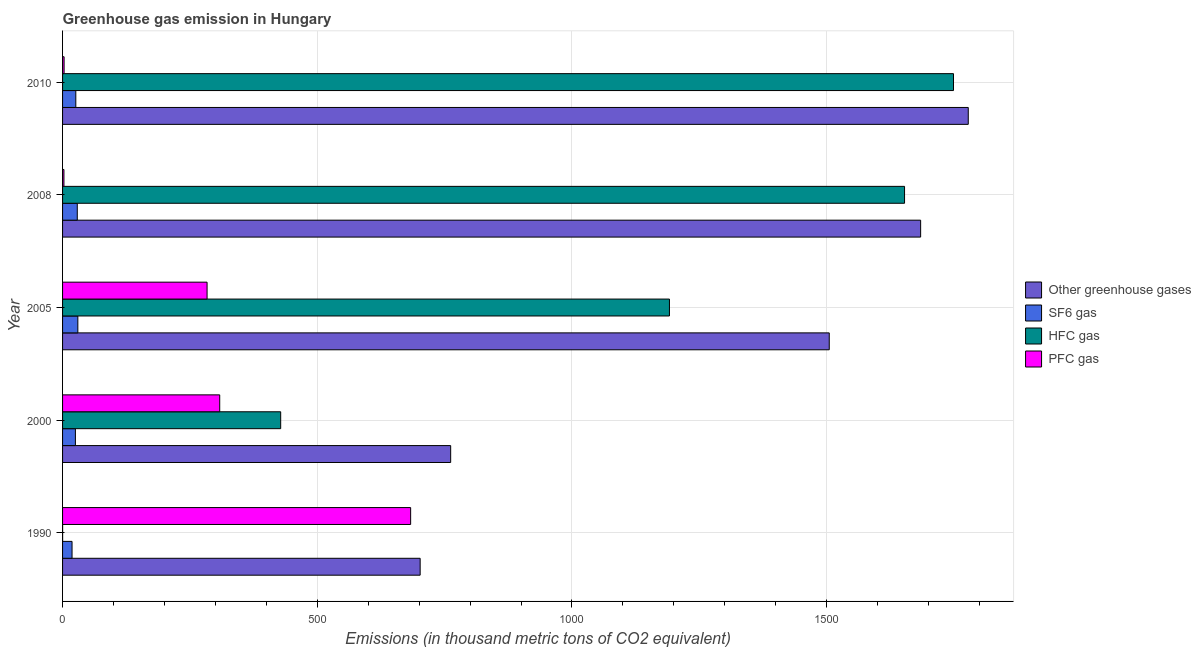How many bars are there on the 1st tick from the bottom?
Keep it short and to the point. 4. Across all years, what is the maximum emission of sf6 gas?
Ensure brevity in your answer.  30. What is the total emission of sf6 gas in the graph?
Make the answer very short. 128.7. What is the difference between the emission of pfc gas in 2005 and that in 2008?
Your answer should be compact. 281. What is the difference between the emission of greenhouse gases in 2000 and the emission of hfc gas in 2008?
Your answer should be compact. -891. What is the average emission of greenhouse gases per year?
Ensure brevity in your answer.  1286.3. In the year 2010, what is the difference between the emission of sf6 gas and emission of hfc gas?
Make the answer very short. -1723. What is the ratio of the emission of hfc gas in 2000 to that in 2008?
Offer a terse response. 0.26. Is the emission of pfc gas in 2000 less than that in 2005?
Offer a very short reply. No. Is the difference between the emission of hfc gas in 2000 and 2008 greater than the difference between the emission of pfc gas in 2000 and 2008?
Your answer should be compact. No. What is the difference between the highest and the second highest emission of sf6 gas?
Your response must be concise. 1.1. What is the difference between the highest and the lowest emission of hfc gas?
Give a very brief answer. 1748.9. In how many years, is the emission of hfc gas greater than the average emission of hfc gas taken over all years?
Your response must be concise. 3. Is the sum of the emission of hfc gas in 2005 and 2008 greater than the maximum emission of sf6 gas across all years?
Provide a short and direct response. Yes. What does the 2nd bar from the top in 2005 represents?
Ensure brevity in your answer.  HFC gas. What does the 3rd bar from the bottom in 2008 represents?
Provide a short and direct response. HFC gas. Is it the case that in every year, the sum of the emission of greenhouse gases and emission of sf6 gas is greater than the emission of hfc gas?
Provide a short and direct response. Yes. Are all the bars in the graph horizontal?
Ensure brevity in your answer.  Yes. How many years are there in the graph?
Offer a terse response. 5. Are the values on the major ticks of X-axis written in scientific E-notation?
Provide a short and direct response. No. Does the graph contain any zero values?
Your response must be concise. No. Does the graph contain grids?
Your answer should be very brief. Yes. What is the title of the graph?
Keep it short and to the point. Greenhouse gas emission in Hungary. Does "Secondary vocational education" appear as one of the legend labels in the graph?
Provide a short and direct response. No. What is the label or title of the X-axis?
Your response must be concise. Emissions (in thousand metric tons of CO2 equivalent). What is the label or title of the Y-axis?
Your response must be concise. Year. What is the Emissions (in thousand metric tons of CO2 equivalent) in Other greenhouse gases in 1990?
Ensure brevity in your answer.  702. What is the Emissions (in thousand metric tons of CO2 equivalent) in SF6 gas in 1990?
Your answer should be very brief. 18.6. What is the Emissions (in thousand metric tons of CO2 equivalent) in PFC gas in 1990?
Provide a succinct answer. 683.3. What is the Emissions (in thousand metric tons of CO2 equivalent) of Other greenhouse gases in 2000?
Ensure brevity in your answer.  761.9. What is the Emissions (in thousand metric tons of CO2 equivalent) of SF6 gas in 2000?
Offer a very short reply. 25.2. What is the Emissions (in thousand metric tons of CO2 equivalent) in HFC gas in 2000?
Offer a terse response. 428.2. What is the Emissions (in thousand metric tons of CO2 equivalent) of PFC gas in 2000?
Provide a succinct answer. 308.5. What is the Emissions (in thousand metric tons of CO2 equivalent) of Other greenhouse gases in 2005?
Provide a succinct answer. 1505.1. What is the Emissions (in thousand metric tons of CO2 equivalent) in SF6 gas in 2005?
Provide a succinct answer. 30. What is the Emissions (in thousand metric tons of CO2 equivalent) of HFC gas in 2005?
Keep it short and to the point. 1191.4. What is the Emissions (in thousand metric tons of CO2 equivalent) of PFC gas in 2005?
Make the answer very short. 283.7. What is the Emissions (in thousand metric tons of CO2 equivalent) in Other greenhouse gases in 2008?
Keep it short and to the point. 1684.5. What is the Emissions (in thousand metric tons of CO2 equivalent) of SF6 gas in 2008?
Give a very brief answer. 28.9. What is the Emissions (in thousand metric tons of CO2 equivalent) in HFC gas in 2008?
Your response must be concise. 1652.9. What is the Emissions (in thousand metric tons of CO2 equivalent) in Other greenhouse gases in 2010?
Your answer should be compact. 1778. What is the Emissions (in thousand metric tons of CO2 equivalent) in SF6 gas in 2010?
Keep it short and to the point. 26. What is the Emissions (in thousand metric tons of CO2 equivalent) of HFC gas in 2010?
Your answer should be very brief. 1749. What is the Emissions (in thousand metric tons of CO2 equivalent) in PFC gas in 2010?
Your answer should be very brief. 3. Across all years, what is the maximum Emissions (in thousand metric tons of CO2 equivalent) of Other greenhouse gases?
Give a very brief answer. 1778. Across all years, what is the maximum Emissions (in thousand metric tons of CO2 equivalent) in SF6 gas?
Your answer should be very brief. 30. Across all years, what is the maximum Emissions (in thousand metric tons of CO2 equivalent) in HFC gas?
Offer a very short reply. 1749. Across all years, what is the maximum Emissions (in thousand metric tons of CO2 equivalent) of PFC gas?
Make the answer very short. 683.3. Across all years, what is the minimum Emissions (in thousand metric tons of CO2 equivalent) of Other greenhouse gases?
Offer a terse response. 702. Across all years, what is the minimum Emissions (in thousand metric tons of CO2 equivalent) of HFC gas?
Offer a terse response. 0.1. Across all years, what is the minimum Emissions (in thousand metric tons of CO2 equivalent) in PFC gas?
Offer a very short reply. 2.7. What is the total Emissions (in thousand metric tons of CO2 equivalent) of Other greenhouse gases in the graph?
Keep it short and to the point. 6431.5. What is the total Emissions (in thousand metric tons of CO2 equivalent) of SF6 gas in the graph?
Give a very brief answer. 128.7. What is the total Emissions (in thousand metric tons of CO2 equivalent) of HFC gas in the graph?
Your answer should be very brief. 5021.6. What is the total Emissions (in thousand metric tons of CO2 equivalent) in PFC gas in the graph?
Make the answer very short. 1281.2. What is the difference between the Emissions (in thousand metric tons of CO2 equivalent) in Other greenhouse gases in 1990 and that in 2000?
Ensure brevity in your answer.  -59.9. What is the difference between the Emissions (in thousand metric tons of CO2 equivalent) in SF6 gas in 1990 and that in 2000?
Offer a terse response. -6.6. What is the difference between the Emissions (in thousand metric tons of CO2 equivalent) of HFC gas in 1990 and that in 2000?
Offer a terse response. -428.1. What is the difference between the Emissions (in thousand metric tons of CO2 equivalent) in PFC gas in 1990 and that in 2000?
Make the answer very short. 374.8. What is the difference between the Emissions (in thousand metric tons of CO2 equivalent) of Other greenhouse gases in 1990 and that in 2005?
Offer a very short reply. -803.1. What is the difference between the Emissions (in thousand metric tons of CO2 equivalent) in HFC gas in 1990 and that in 2005?
Offer a very short reply. -1191.3. What is the difference between the Emissions (in thousand metric tons of CO2 equivalent) of PFC gas in 1990 and that in 2005?
Offer a terse response. 399.6. What is the difference between the Emissions (in thousand metric tons of CO2 equivalent) of Other greenhouse gases in 1990 and that in 2008?
Provide a succinct answer. -982.5. What is the difference between the Emissions (in thousand metric tons of CO2 equivalent) of SF6 gas in 1990 and that in 2008?
Provide a short and direct response. -10.3. What is the difference between the Emissions (in thousand metric tons of CO2 equivalent) in HFC gas in 1990 and that in 2008?
Keep it short and to the point. -1652.8. What is the difference between the Emissions (in thousand metric tons of CO2 equivalent) in PFC gas in 1990 and that in 2008?
Offer a terse response. 680.6. What is the difference between the Emissions (in thousand metric tons of CO2 equivalent) of Other greenhouse gases in 1990 and that in 2010?
Keep it short and to the point. -1076. What is the difference between the Emissions (in thousand metric tons of CO2 equivalent) in HFC gas in 1990 and that in 2010?
Your answer should be very brief. -1748.9. What is the difference between the Emissions (in thousand metric tons of CO2 equivalent) of PFC gas in 1990 and that in 2010?
Offer a terse response. 680.3. What is the difference between the Emissions (in thousand metric tons of CO2 equivalent) in Other greenhouse gases in 2000 and that in 2005?
Make the answer very short. -743.2. What is the difference between the Emissions (in thousand metric tons of CO2 equivalent) of HFC gas in 2000 and that in 2005?
Provide a short and direct response. -763.2. What is the difference between the Emissions (in thousand metric tons of CO2 equivalent) in PFC gas in 2000 and that in 2005?
Offer a very short reply. 24.8. What is the difference between the Emissions (in thousand metric tons of CO2 equivalent) in Other greenhouse gases in 2000 and that in 2008?
Offer a terse response. -922.6. What is the difference between the Emissions (in thousand metric tons of CO2 equivalent) of HFC gas in 2000 and that in 2008?
Offer a very short reply. -1224.7. What is the difference between the Emissions (in thousand metric tons of CO2 equivalent) in PFC gas in 2000 and that in 2008?
Your answer should be very brief. 305.8. What is the difference between the Emissions (in thousand metric tons of CO2 equivalent) in Other greenhouse gases in 2000 and that in 2010?
Offer a very short reply. -1016.1. What is the difference between the Emissions (in thousand metric tons of CO2 equivalent) in SF6 gas in 2000 and that in 2010?
Offer a terse response. -0.8. What is the difference between the Emissions (in thousand metric tons of CO2 equivalent) in HFC gas in 2000 and that in 2010?
Your answer should be very brief. -1320.8. What is the difference between the Emissions (in thousand metric tons of CO2 equivalent) in PFC gas in 2000 and that in 2010?
Keep it short and to the point. 305.5. What is the difference between the Emissions (in thousand metric tons of CO2 equivalent) of Other greenhouse gases in 2005 and that in 2008?
Provide a short and direct response. -179.4. What is the difference between the Emissions (in thousand metric tons of CO2 equivalent) in HFC gas in 2005 and that in 2008?
Your response must be concise. -461.5. What is the difference between the Emissions (in thousand metric tons of CO2 equivalent) of PFC gas in 2005 and that in 2008?
Ensure brevity in your answer.  281. What is the difference between the Emissions (in thousand metric tons of CO2 equivalent) in Other greenhouse gases in 2005 and that in 2010?
Make the answer very short. -272.9. What is the difference between the Emissions (in thousand metric tons of CO2 equivalent) of SF6 gas in 2005 and that in 2010?
Your response must be concise. 4. What is the difference between the Emissions (in thousand metric tons of CO2 equivalent) in HFC gas in 2005 and that in 2010?
Provide a short and direct response. -557.6. What is the difference between the Emissions (in thousand metric tons of CO2 equivalent) of PFC gas in 2005 and that in 2010?
Your response must be concise. 280.7. What is the difference between the Emissions (in thousand metric tons of CO2 equivalent) in Other greenhouse gases in 2008 and that in 2010?
Your answer should be compact. -93.5. What is the difference between the Emissions (in thousand metric tons of CO2 equivalent) in SF6 gas in 2008 and that in 2010?
Give a very brief answer. 2.9. What is the difference between the Emissions (in thousand metric tons of CO2 equivalent) in HFC gas in 2008 and that in 2010?
Provide a short and direct response. -96.1. What is the difference between the Emissions (in thousand metric tons of CO2 equivalent) in Other greenhouse gases in 1990 and the Emissions (in thousand metric tons of CO2 equivalent) in SF6 gas in 2000?
Make the answer very short. 676.8. What is the difference between the Emissions (in thousand metric tons of CO2 equivalent) of Other greenhouse gases in 1990 and the Emissions (in thousand metric tons of CO2 equivalent) of HFC gas in 2000?
Your response must be concise. 273.8. What is the difference between the Emissions (in thousand metric tons of CO2 equivalent) of Other greenhouse gases in 1990 and the Emissions (in thousand metric tons of CO2 equivalent) of PFC gas in 2000?
Offer a very short reply. 393.5. What is the difference between the Emissions (in thousand metric tons of CO2 equivalent) of SF6 gas in 1990 and the Emissions (in thousand metric tons of CO2 equivalent) of HFC gas in 2000?
Your answer should be very brief. -409.6. What is the difference between the Emissions (in thousand metric tons of CO2 equivalent) of SF6 gas in 1990 and the Emissions (in thousand metric tons of CO2 equivalent) of PFC gas in 2000?
Offer a very short reply. -289.9. What is the difference between the Emissions (in thousand metric tons of CO2 equivalent) of HFC gas in 1990 and the Emissions (in thousand metric tons of CO2 equivalent) of PFC gas in 2000?
Your response must be concise. -308.4. What is the difference between the Emissions (in thousand metric tons of CO2 equivalent) of Other greenhouse gases in 1990 and the Emissions (in thousand metric tons of CO2 equivalent) of SF6 gas in 2005?
Give a very brief answer. 672. What is the difference between the Emissions (in thousand metric tons of CO2 equivalent) in Other greenhouse gases in 1990 and the Emissions (in thousand metric tons of CO2 equivalent) in HFC gas in 2005?
Your response must be concise. -489.4. What is the difference between the Emissions (in thousand metric tons of CO2 equivalent) in Other greenhouse gases in 1990 and the Emissions (in thousand metric tons of CO2 equivalent) in PFC gas in 2005?
Give a very brief answer. 418.3. What is the difference between the Emissions (in thousand metric tons of CO2 equivalent) of SF6 gas in 1990 and the Emissions (in thousand metric tons of CO2 equivalent) of HFC gas in 2005?
Provide a short and direct response. -1172.8. What is the difference between the Emissions (in thousand metric tons of CO2 equivalent) in SF6 gas in 1990 and the Emissions (in thousand metric tons of CO2 equivalent) in PFC gas in 2005?
Offer a terse response. -265.1. What is the difference between the Emissions (in thousand metric tons of CO2 equivalent) in HFC gas in 1990 and the Emissions (in thousand metric tons of CO2 equivalent) in PFC gas in 2005?
Provide a succinct answer. -283.6. What is the difference between the Emissions (in thousand metric tons of CO2 equivalent) in Other greenhouse gases in 1990 and the Emissions (in thousand metric tons of CO2 equivalent) in SF6 gas in 2008?
Your answer should be very brief. 673.1. What is the difference between the Emissions (in thousand metric tons of CO2 equivalent) of Other greenhouse gases in 1990 and the Emissions (in thousand metric tons of CO2 equivalent) of HFC gas in 2008?
Offer a terse response. -950.9. What is the difference between the Emissions (in thousand metric tons of CO2 equivalent) of Other greenhouse gases in 1990 and the Emissions (in thousand metric tons of CO2 equivalent) of PFC gas in 2008?
Offer a terse response. 699.3. What is the difference between the Emissions (in thousand metric tons of CO2 equivalent) of SF6 gas in 1990 and the Emissions (in thousand metric tons of CO2 equivalent) of HFC gas in 2008?
Your answer should be compact. -1634.3. What is the difference between the Emissions (in thousand metric tons of CO2 equivalent) of HFC gas in 1990 and the Emissions (in thousand metric tons of CO2 equivalent) of PFC gas in 2008?
Offer a very short reply. -2.6. What is the difference between the Emissions (in thousand metric tons of CO2 equivalent) in Other greenhouse gases in 1990 and the Emissions (in thousand metric tons of CO2 equivalent) in SF6 gas in 2010?
Give a very brief answer. 676. What is the difference between the Emissions (in thousand metric tons of CO2 equivalent) of Other greenhouse gases in 1990 and the Emissions (in thousand metric tons of CO2 equivalent) of HFC gas in 2010?
Your response must be concise. -1047. What is the difference between the Emissions (in thousand metric tons of CO2 equivalent) of Other greenhouse gases in 1990 and the Emissions (in thousand metric tons of CO2 equivalent) of PFC gas in 2010?
Your response must be concise. 699. What is the difference between the Emissions (in thousand metric tons of CO2 equivalent) of SF6 gas in 1990 and the Emissions (in thousand metric tons of CO2 equivalent) of HFC gas in 2010?
Offer a very short reply. -1730.4. What is the difference between the Emissions (in thousand metric tons of CO2 equivalent) in SF6 gas in 1990 and the Emissions (in thousand metric tons of CO2 equivalent) in PFC gas in 2010?
Offer a very short reply. 15.6. What is the difference between the Emissions (in thousand metric tons of CO2 equivalent) in Other greenhouse gases in 2000 and the Emissions (in thousand metric tons of CO2 equivalent) in SF6 gas in 2005?
Keep it short and to the point. 731.9. What is the difference between the Emissions (in thousand metric tons of CO2 equivalent) in Other greenhouse gases in 2000 and the Emissions (in thousand metric tons of CO2 equivalent) in HFC gas in 2005?
Offer a very short reply. -429.5. What is the difference between the Emissions (in thousand metric tons of CO2 equivalent) of Other greenhouse gases in 2000 and the Emissions (in thousand metric tons of CO2 equivalent) of PFC gas in 2005?
Your answer should be compact. 478.2. What is the difference between the Emissions (in thousand metric tons of CO2 equivalent) in SF6 gas in 2000 and the Emissions (in thousand metric tons of CO2 equivalent) in HFC gas in 2005?
Ensure brevity in your answer.  -1166.2. What is the difference between the Emissions (in thousand metric tons of CO2 equivalent) of SF6 gas in 2000 and the Emissions (in thousand metric tons of CO2 equivalent) of PFC gas in 2005?
Your answer should be very brief. -258.5. What is the difference between the Emissions (in thousand metric tons of CO2 equivalent) in HFC gas in 2000 and the Emissions (in thousand metric tons of CO2 equivalent) in PFC gas in 2005?
Provide a short and direct response. 144.5. What is the difference between the Emissions (in thousand metric tons of CO2 equivalent) of Other greenhouse gases in 2000 and the Emissions (in thousand metric tons of CO2 equivalent) of SF6 gas in 2008?
Provide a succinct answer. 733. What is the difference between the Emissions (in thousand metric tons of CO2 equivalent) of Other greenhouse gases in 2000 and the Emissions (in thousand metric tons of CO2 equivalent) of HFC gas in 2008?
Provide a succinct answer. -891. What is the difference between the Emissions (in thousand metric tons of CO2 equivalent) of Other greenhouse gases in 2000 and the Emissions (in thousand metric tons of CO2 equivalent) of PFC gas in 2008?
Ensure brevity in your answer.  759.2. What is the difference between the Emissions (in thousand metric tons of CO2 equivalent) of SF6 gas in 2000 and the Emissions (in thousand metric tons of CO2 equivalent) of HFC gas in 2008?
Make the answer very short. -1627.7. What is the difference between the Emissions (in thousand metric tons of CO2 equivalent) of SF6 gas in 2000 and the Emissions (in thousand metric tons of CO2 equivalent) of PFC gas in 2008?
Your answer should be compact. 22.5. What is the difference between the Emissions (in thousand metric tons of CO2 equivalent) in HFC gas in 2000 and the Emissions (in thousand metric tons of CO2 equivalent) in PFC gas in 2008?
Keep it short and to the point. 425.5. What is the difference between the Emissions (in thousand metric tons of CO2 equivalent) of Other greenhouse gases in 2000 and the Emissions (in thousand metric tons of CO2 equivalent) of SF6 gas in 2010?
Offer a terse response. 735.9. What is the difference between the Emissions (in thousand metric tons of CO2 equivalent) in Other greenhouse gases in 2000 and the Emissions (in thousand metric tons of CO2 equivalent) in HFC gas in 2010?
Your response must be concise. -987.1. What is the difference between the Emissions (in thousand metric tons of CO2 equivalent) of Other greenhouse gases in 2000 and the Emissions (in thousand metric tons of CO2 equivalent) of PFC gas in 2010?
Your response must be concise. 758.9. What is the difference between the Emissions (in thousand metric tons of CO2 equivalent) of SF6 gas in 2000 and the Emissions (in thousand metric tons of CO2 equivalent) of HFC gas in 2010?
Keep it short and to the point. -1723.8. What is the difference between the Emissions (in thousand metric tons of CO2 equivalent) of HFC gas in 2000 and the Emissions (in thousand metric tons of CO2 equivalent) of PFC gas in 2010?
Provide a short and direct response. 425.2. What is the difference between the Emissions (in thousand metric tons of CO2 equivalent) in Other greenhouse gases in 2005 and the Emissions (in thousand metric tons of CO2 equivalent) in SF6 gas in 2008?
Ensure brevity in your answer.  1476.2. What is the difference between the Emissions (in thousand metric tons of CO2 equivalent) in Other greenhouse gases in 2005 and the Emissions (in thousand metric tons of CO2 equivalent) in HFC gas in 2008?
Keep it short and to the point. -147.8. What is the difference between the Emissions (in thousand metric tons of CO2 equivalent) of Other greenhouse gases in 2005 and the Emissions (in thousand metric tons of CO2 equivalent) of PFC gas in 2008?
Your answer should be compact. 1502.4. What is the difference between the Emissions (in thousand metric tons of CO2 equivalent) in SF6 gas in 2005 and the Emissions (in thousand metric tons of CO2 equivalent) in HFC gas in 2008?
Make the answer very short. -1622.9. What is the difference between the Emissions (in thousand metric tons of CO2 equivalent) in SF6 gas in 2005 and the Emissions (in thousand metric tons of CO2 equivalent) in PFC gas in 2008?
Your answer should be very brief. 27.3. What is the difference between the Emissions (in thousand metric tons of CO2 equivalent) in HFC gas in 2005 and the Emissions (in thousand metric tons of CO2 equivalent) in PFC gas in 2008?
Your response must be concise. 1188.7. What is the difference between the Emissions (in thousand metric tons of CO2 equivalent) of Other greenhouse gases in 2005 and the Emissions (in thousand metric tons of CO2 equivalent) of SF6 gas in 2010?
Offer a very short reply. 1479.1. What is the difference between the Emissions (in thousand metric tons of CO2 equivalent) of Other greenhouse gases in 2005 and the Emissions (in thousand metric tons of CO2 equivalent) of HFC gas in 2010?
Give a very brief answer. -243.9. What is the difference between the Emissions (in thousand metric tons of CO2 equivalent) in Other greenhouse gases in 2005 and the Emissions (in thousand metric tons of CO2 equivalent) in PFC gas in 2010?
Ensure brevity in your answer.  1502.1. What is the difference between the Emissions (in thousand metric tons of CO2 equivalent) of SF6 gas in 2005 and the Emissions (in thousand metric tons of CO2 equivalent) of HFC gas in 2010?
Offer a very short reply. -1719. What is the difference between the Emissions (in thousand metric tons of CO2 equivalent) of SF6 gas in 2005 and the Emissions (in thousand metric tons of CO2 equivalent) of PFC gas in 2010?
Your answer should be compact. 27. What is the difference between the Emissions (in thousand metric tons of CO2 equivalent) of HFC gas in 2005 and the Emissions (in thousand metric tons of CO2 equivalent) of PFC gas in 2010?
Give a very brief answer. 1188.4. What is the difference between the Emissions (in thousand metric tons of CO2 equivalent) in Other greenhouse gases in 2008 and the Emissions (in thousand metric tons of CO2 equivalent) in SF6 gas in 2010?
Ensure brevity in your answer.  1658.5. What is the difference between the Emissions (in thousand metric tons of CO2 equivalent) of Other greenhouse gases in 2008 and the Emissions (in thousand metric tons of CO2 equivalent) of HFC gas in 2010?
Provide a short and direct response. -64.5. What is the difference between the Emissions (in thousand metric tons of CO2 equivalent) of Other greenhouse gases in 2008 and the Emissions (in thousand metric tons of CO2 equivalent) of PFC gas in 2010?
Provide a succinct answer. 1681.5. What is the difference between the Emissions (in thousand metric tons of CO2 equivalent) of SF6 gas in 2008 and the Emissions (in thousand metric tons of CO2 equivalent) of HFC gas in 2010?
Give a very brief answer. -1720.1. What is the difference between the Emissions (in thousand metric tons of CO2 equivalent) in SF6 gas in 2008 and the Emissions (in thousand metric tons of CO2 equivalent) in PFC gas in 2010?
Keep it short and to the point. 25.9. What is the difference between the Emissions (in thousand metric tons of CO2 equivalent) in HFC gas in 2008 and the Emissions (in thousand metric tons of CO2 equivalent) in PFC gas in 2010?
Offer a terse response. 1649.9. What is the average Emissions (in thousand metric tons of CO2 equivalent) of Other greenhouse gases per year?
Provide a short and direct response. 1286.3. What is the average Emissions (in thousand metric tons of CO2 equivalent) of SF6 gas per year?
Your response must be concise. 25.74. What is the average Emissions (in thousand metric tons of CO2 equivalent) in HFC gas per year?
Offer a very short reply. 1004.32. What is the average Emissions (in thousand metric tons of CO2 equivalent) of PFC gas per year?
Keep it short and to the point. 256.24. In the year 1990, what is the difference between the Emissions (in thousand metric tons of CO2 equivalent) of Other greenhouse gases and Emissions (in thousand metric tons of CO2 equivalent) of SF6 gas?
Ensure brevity in your answer.  683.4. In the year 1990, what is the difference between the Emissions (in thousand metric tons of CO2 equivalent) in Other greenhouse gases and Emissions (in thousand metric tons of CO2 equivalent) in HFC gas?
Make the answer very short. 701.9. In the year 1990, what is the difference between the Emissions (in thousand metric tons of CO2 equivalent) of Other greenhouse gases and Emissions (in thousand metric tons of CO2 equivalent) of PFC gas?
Offer a very short reply. 18.7. In the year 1990, what is the difference between the Emissions (in thousand metric tons of CO2 equivalent) of SF6 gas and Emissions (in thousand metric tons of CO2 equivalent) of HFC gas?
Provide a succinct answer. 18.5. In the year 1990, what is the difference between the Emissions (in thousand metric tons of CO2 equivalent) of SF6 gas and Emissions (in thousand metric tons of CO2 equivalent) of PFC gas?
Provide a succinct answer. -664.7. In the year 1990, what is the difference between the Emissions (in thousand metric tons of CO2 equivalent) of HFC gas and Emissions (in thousand metric tons of CO2 equivalent) of PFC gas?
Keep it short and to the point. -683.2. In the year 2000, what is the difference between the Emissions (in thousand metric tons of CO2 equivalent) of Other greenhouse gases and Emissions (in thousand metric tons of CO2 equivalent) of SF6 gas?
Make the answer very short. 736.7. In the year 2000, what is the difference between the Emissions (in thousand metric tons of CO2 equivalent) in Other greenhouse gases and Emissions (in thousand metric tons of CO2 equivalent) in HFC gas?
Provide a succinct answer. 333.7. In the year 2000, what is the difference between the Emissions (in thousand metric tons of CO2 equivalent) in Other greenhouse gases and Emissions (in thousand metric tons of CO2 equivalent) in PFC gas?
Keep it short and to the point. 453.4. In the year 2000, what is the difference between the Emissions (in thousand metric tons of CO2 equivalent) in SF6 gas and Emissions (in thousand metric tons of CO2 equivalent) in HFC gas?
Your answer should be compact. -403. In the year 2000, what is the difference between the Emissions (in thousand metric tons of CO2 equivalent) of SF6 gas and Emissions (in thousand metric tons of CO2 equivalent) of PFC gas?
Your answer should be very brief. -283.3. In the year 2000, what is the difference between the Emissions (in thousand metric tons of CO2 equivalent) in HFC gas and Emissions (in thousand metric tons of CO2 equivalent) in PFC gas?
Provide a short and direct response. 119.7. In the year 2005, what is the difference between the Emissions (in thousand metric tons of CO2 equivalent) in Other greenhouse gases and Emissions (in thousand metric tons of CO2 equivalent) in SF6 gas?
Give a very brief answer. 1475.1. In the year 2005, what is the difference between the Emissions (in thousand metric tons of CO2 equivalent) of Other greenhouse gases and Emissions (in thousand metric tons of CO2 equivalent) of HFC gas?
Offer a very short reply. 313.7. In the year 2005, what is the difference between the Emissions (in thousand metric tons of CO2 equivalent) of Other greenhouse gases and Emissions (in thousand metric tons of CO2 equivalent) of PFC gas?
Ensure brevity in your answer.  1221.4. In the year 2005, what is the difference between the Emissions (in thousand metric tons of CO2 equivalent) of SF6 gas and Emissions (in thousand metric tons of CO2 equivalent) of HFC gas?
Give a very brief answer. -1161.4. In the year 2005, what is the difference between the Emissions (in thousand metric tons of CO2 equivalent) in SF6 gas and Emissions (in thousand metric tons of CO2 equivalent) in PFC gas?
Offer a very short reply. -253.7. In the year 2005, what is the difference between the Emissions (in thousand metric tons of CO2 equivalent) in HFC gas and Emissions (in thousand metric tons of CO2 equivalent) in PFC gas?
Keep it short and to the point. 907.7. In the year 2008, what is the difference between the Emissions (in thousand metric tons of CO2 equivalent) of Other greenhouse gases and Emissions (in thousand metric tons of CO2 equivalent) of SF6 gas?
Keep it short and to the point. 1655.6. In the year 2008, what is the difference between the Emissions (in thousand metric tons of CO2 equivalent) in Other greenhouse gases and Emissions (in thousand metric tons of CO2 equivalent) in HFC gas?
Keep it short and to the point. 31.6. In the year 2008, what is the difference between the Emissions (in thousand metric tons of CO2 equivalent) in Other greenhouse gases and Emissions (in thousand metric tons of CO2 equivalent) in PFC gas?
Ensure brevity in your answer.  1681.8. In the year 2008, what is the difference between the Emissions (in thousand metric tons of CO2 equivalent) in SF6 gas and Emissions (in thousand metric tons of CO2 equivalent) in HFC gas?
Provide a short and direct response. -1624. In the year 2008, what is the difference between the Emissions (in thousand metric tons of CO2 equivalent) of SF6 gas and Emissions (in thousand metric tons of CO2 equivalent) of PFC gas?
Make the answer very short. 26.2. In the year 2008, what is the difference between the Emissions (in thousand metric tons of CO2 equivalent) of HFC gas and Emissions (in thousand metric tons of CO2 equivalent) of PFC gas?
Your answer should be compact. 1650.2. In the year 2010, what is the difference between the Emissions (in thousand metric tons of CO2 equivalent) of Other greenhouse gases and Emissions (in thousand metric tons of CO2 equivalent) of SF6 gas?
Your response must be concise. 1752. In the year 2010, what is the difference between the Emissions (in thousand metric tons of CO2 equivalent) in Other greenhouse gases and Emissions (in thousand metric tons of CO2 equivalent) in PFC gas?
Keep it short and to the point. 1775. In the year 2010, what is the difference between the Emissions (in thousand metric tons of CO2 equivalent) of SF6 gas and Emissions (in thousand metric tons of CO2 equivalent) of HFC gas?
Your answer should be compact. -1723. In the year 2010, what is the difference between the Emissions (in thousand metric tons of CO2 equivalent) in HFC gas and Emissions (in thousand metric tons of CO2 equivalent) in PFC gas?
Give a very brief answer. 1746. What is the ratio of the Emissions (in thousand metric tons of CO2 equivalent) of Other greenhouse gases in 1990 to that in 2000?
Provide a short and direct response. 0.92. What is the ratio of the Emissions (in thousand metric tons of CO2 equivalent) in SF6 gas in 1990 to that in 2000?
Your response must be concise. 0.74. What is the ratio of the Emissions (in thousand metric tons of CO2 equivalent) of HFC gas in 1990 to that in 2000?
Make the answer very short. 0. What is the ratio of the Emissions (in thousand metric tons of CO2 equivalent) in PFC gas in 1990 to that in 2000?
Ensure brevity in your answer.  2.21. What is the ratio of the Emissions (in thousand metric tons of CO2 equivalent) in Other greenhouse gases in 1990 to that in 2005?
Give a very brief answer. 0.47. What is the ratio of the Emissions (in thousand metric tons of CO2 equivalent) in SF6 gas in 1990 to that in 2005?
Give a very brief answer. 0.62. What is the ratio of the Emissions (in thousand metric tons of CO2 equivalent) in HFC gas in 1990 to that in 2005?
Offer a terse response. 0. What is the ratio of the Emissions (in thousand metric tons of CO2 equivalent) in PFC gas in 1990 to that in 2005?
Provide a succinct answer. 2.41. What is the ratio of the Emissions (in thousand metric tons of CO2 equivalent) of Other greenhouse gases in 1990 to that in 2008?
Your answer should be compact. 0.42. What is the ratio of the Emissions (in thousand metric tons of CO2 equivalent) of SF6 gas in 1990 to that in 2008?
Ensure brevity in your answer.  0.64. What is the ratio of the Emissions (in thousand metric tons of CO2 equivalent) of PFC gas in 1990 to that in 2008?
Your answer should be compact. 253.07. What is the ratio of the Emissions (in thousand metric tons of CO2 equivalent) of Other greenhouse gases in 1990 to that in 2010?
Offer a very short reply. 0.39. What is the ratio of the Emissions (in thousand metric tons of CO2 equivalent) of SF6 gas in 1990 to that in 2010?
Your answer should be very brief. 0.72. What is the ratio of the Emissions (in thousand metric tons of CO2 equivalent) of PFC gas in 1990 to that in 2010?
Your response must be concise. 227.77. What is the ratio of the Emissions (in thousand metric tons of CO2 equivalent) of Other greenhouse gases in 2000 to that in 2005?
Offer a very short reply. 0.51. What is the ratio of the Emissions (in thousand metric tons of CO2 equivalent) in SF6 gas in 2000 to that in 2005?
Provide a short and direct response. 0.84. What is the ratio of the Emissions (in thousand metric tons of CO2 equivalent) of HFC gas in 2000 to that in 2005?
Your answer should be very brief. 0.36. What is the ratio of the Emissions (in thousand metric tons of CO2 equivalent) in PFC gas in 2000 to that in 2005?
Ensure brevity in your answer.  1.09. What is the ratio of the Emissions (in thousand metric tons of CO2 equivalent) in Other greenhouse gases in 2000 to that in 2008?
Provide a succinct answer. 0.45. What is the ratio of the Emissions (in thousand metric tons of CO2 equivalent) of SF6 gas in 2000 to that in 2008?
Keep it short and to the point. 0.87. What is the ratio of the Emissions (in thousand metric tons of CO2 equivalent) in HFC gas in 2000 to that in 2008?
Offer a very short reply. 0.26. What is the ratio of the Emissions (in thousand metric tons of CO2 equivalent) in PFC gas in 2000 to that in 2008?
Offer a terse response. 114.26. What is the ratio of the Emissions (in thousand metric tons of CO2 equivalent) in Other greenhouse gases in 2000 to that in 2010?
Make the answer very short. 0.43. What is the ratio of the Emissions (in thousand metric tons of CO2 equivalent) of SF6 gas in 2000 to that in 2010?
Provide a short and direct response. 0.97. What is the ratio of the Emissions (in thousand metric tons of CO2 equivalent) in HFC gas in 2000 to that in 2010?
Your answer should be very brief. 0.24. What is the ratio of the Emissions (in thousand metric tons of CO2 equivalent) in PFC gas in 2000 to that in 2010?
Make the answer very short. 102.83. What is the ratio of the Emissions (in thousand metric tons of CO2 equivalent) in Other greenhouse gases in 2005 to that in 2008?
Offer a very short reply. 0.89. What is the ratio of the Emissions (in thousand metric tons of CO2 equivalent) of SF6 gas in 2005 to that in 2008?
Provide a short and direct response. 1.04. What is the ratio of the Emissions (in thousand metric tons of CO2 equivalent) in HFC gas in 2005 to that in 2008?
Give a very brief answer. 0.72. What is the ratio of the Emissions (in thousand metric tons of CO2 equivalent) of PFC gas in 2005 to that in 2008?
Your answer should be very brief. 105.07. What is the ratio of the Emissions (in thousand metric tons of CO2 equivalent) in Other greenhouse gases in 2005 to that in 2010?
Offer a terse response. 0.85. What is the ratio of the Emissions (in thousand metric tons of CO2 equivalent) of SF6 gas in 2005 to that in 2010?
Your response must be concise. 1.15. What is the ratio of the Emissions (in thousand metric tons of CO2 equivalent) of HFC gas in 2005 to that in 2010?
Offer a very short reply. 0.68. What is the ratio of the Emissions (in thousand metric tons of CO2 equivalent) of PFC gas in 2005 to that in 2010?
Offer a terse response. 94.57. What is the ratio of the Emissions (in thousand metric tons of CO2 equivalent) in SF6 gas in 2008 to that in 2010?
Your response must be concise. 1.11. What is the ratio of the Emissions (in thousand metric tons of CO2 equivalent) of HFC gas in 2008 to that in 2010?
Give a very brief answer. 0.95. What is the ratio of the Emissions (in thousand metric tons of CO2 equivalent) of PFC gas in 2008 to that in 2010?
Make the answer very short. 0.9. What is the difference between the highest and the second highest Emissions (in thousand metric tons of CO2 equivalent) in Other greenhouse gases?
Offer a very short reply. 93.5. What is the difference between the highest and the second highest Emissions (in thousand metric tons of CO2 equivalent) in HFC gas?
Your response must be concise. 96.1. What is the difference between the highest and the second highest Emissions (in thousand metric tons of CO2 equivalent) of PFC gas?
Give a very brief answer. 374.8. What is the difference between the highest and the lowest Emissions (in thousand metric tons of CO2 equivalent) of Other greenhouse gases?
Your response must be concise. 1076. What is the difference between the highest and the lowest Emissions (in thousand metric tons of CO2 equivalent) in HFC gas?
Offer a terse response. 1748.9. What is the difference between the highest and the lowest Emissions (in thousand metric tons of CO2 equivalent) of PFC gas?
Make the answer very short. 680.6. 